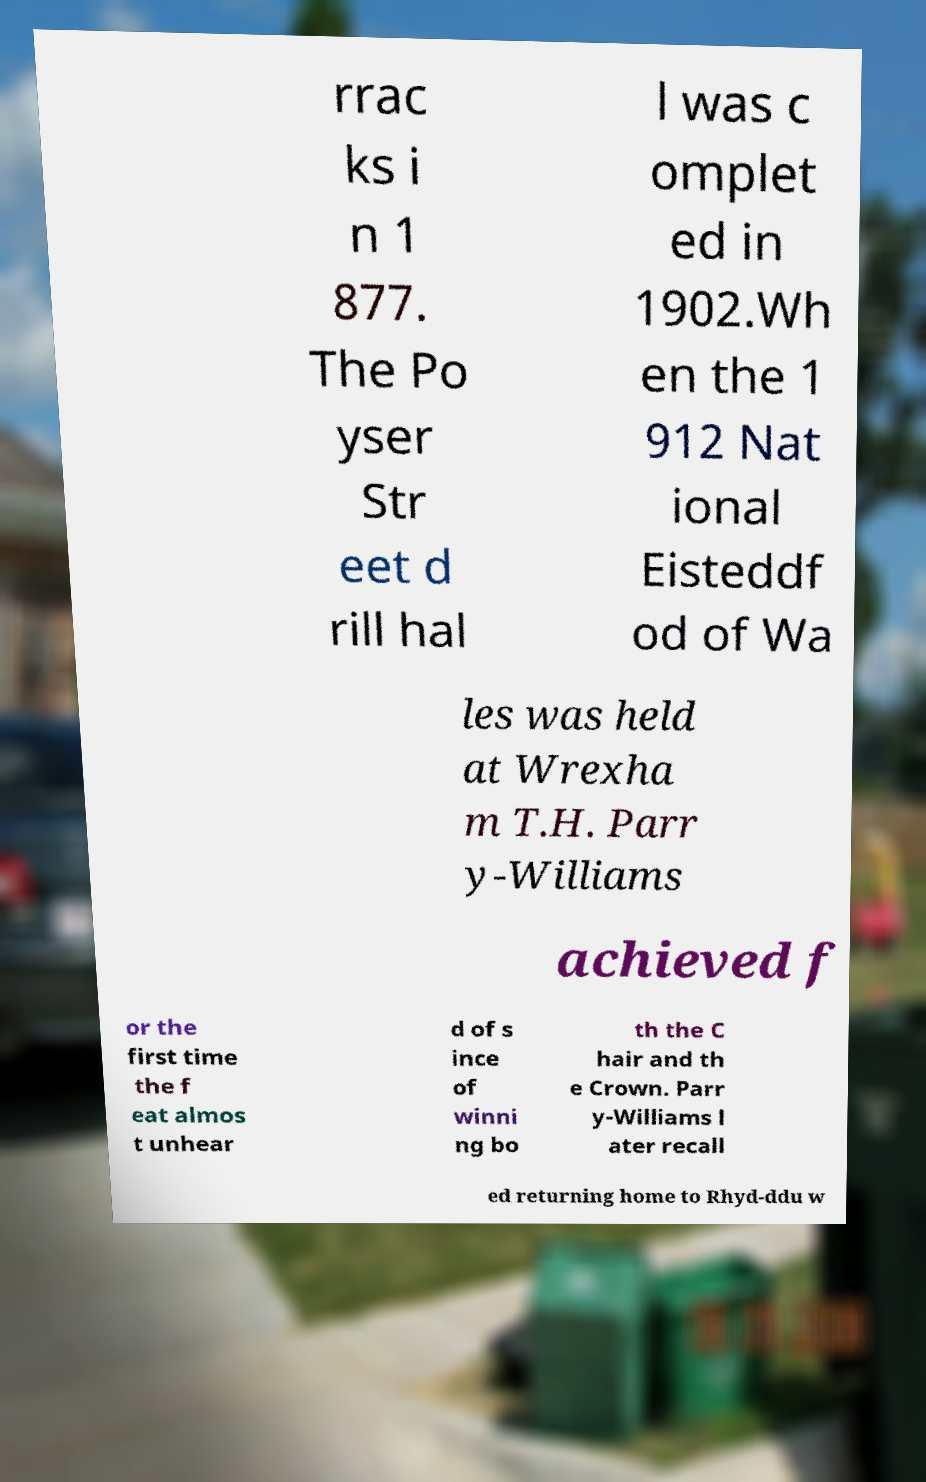Please identify and transcribe the text found in this image. rrac ks i n 1 877. The Po yser Str eet d rill hal l was c omplet ed in 1902.Wh en the 1 912 Nat ional Eisteddf od of Wa les was held at Wrexha m T.H. Parr y-Williams achieved f or the first time the f eat almos t unhear d of s ince of winni ng bo th the C hair and th e Crown. Parr y-Williams l ater recall ed returning home to Rhyd-ddu w 